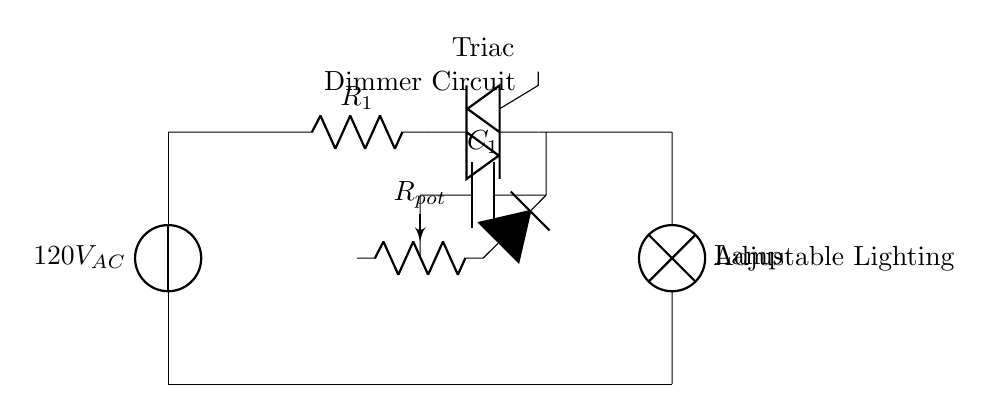what is the voltage of the power source? The circuit is connected to a power source labeled as 120V AC, indicating the standard voltage for this application.
Answer: 120V AC what type of component is used for the adjustable resistance? In the circuit, a potentiometer labeled R pot is used, which allows for varying resistance to adjust the lighting intensity.
Answer: Potentiometer what component controls the light intensity? The Triac in the circuit is responsible for controlling the light intensity by managing the power delivered to the lamp based on the settings of the potentiometer.
Answer: Triac what is the purpose of the capacitor? The capacitor labeled C one in the circuit is placed in series with the Triac and helps in phase control, contributing to the adjustment of the light intensity.
Answer: Phase control how many main components are in this dimmer circuit? The circuit consists of five main components: the voltage source, potentiometer, Triac, capacitor, and light bulb, which together form the dimmer configuration.
Answer: Five what is the function of the Diac in this circuit? The Diac between the potentiometer and the capacitor triggers the Triac at a specific voltage, allowing the dimmer to activate at the desired setting for light intensity.
Answer: Triggering Triac what type of load is connected to this circuit? The load connected to the circuit is a lamp, which represents the adjustable lighting that the circuit controls.
Answer: Lamp 